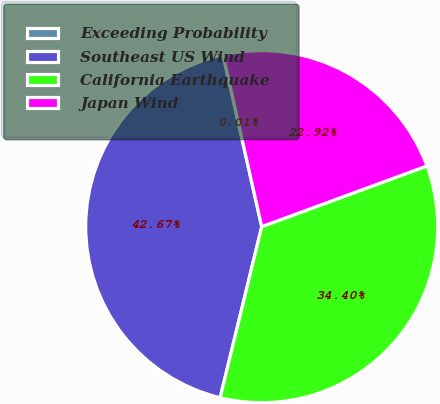Convert chart. <chart><loc_0><loc_0><loc_500><loc_500><pie_chart><fcel>Exceeding Probability<fcel>Southeast US Wind<fcel>California Earthquake<fcel>Japan Wind<nl><fcel>0.01%<fcel>42.67%<fcel>34.4%<fcel>22.92%<nl></chart> 